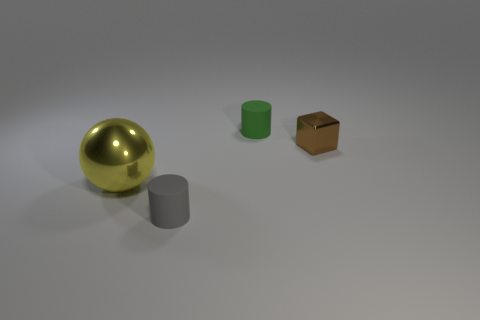Add 3 tiny gray blocks. How many objects exist? 7 Subtract all blocks. How many objects are left? 3 Add 3 small red metal objects. How many small red metal objects exist? 3 Subtract 0 red cubes. How many objects are left? 4 Subtract all big things. Subtract all large yellow spheres. How many objects are left? 2 Add 1 brown metallic things. How many brown metallic things are left? 2 